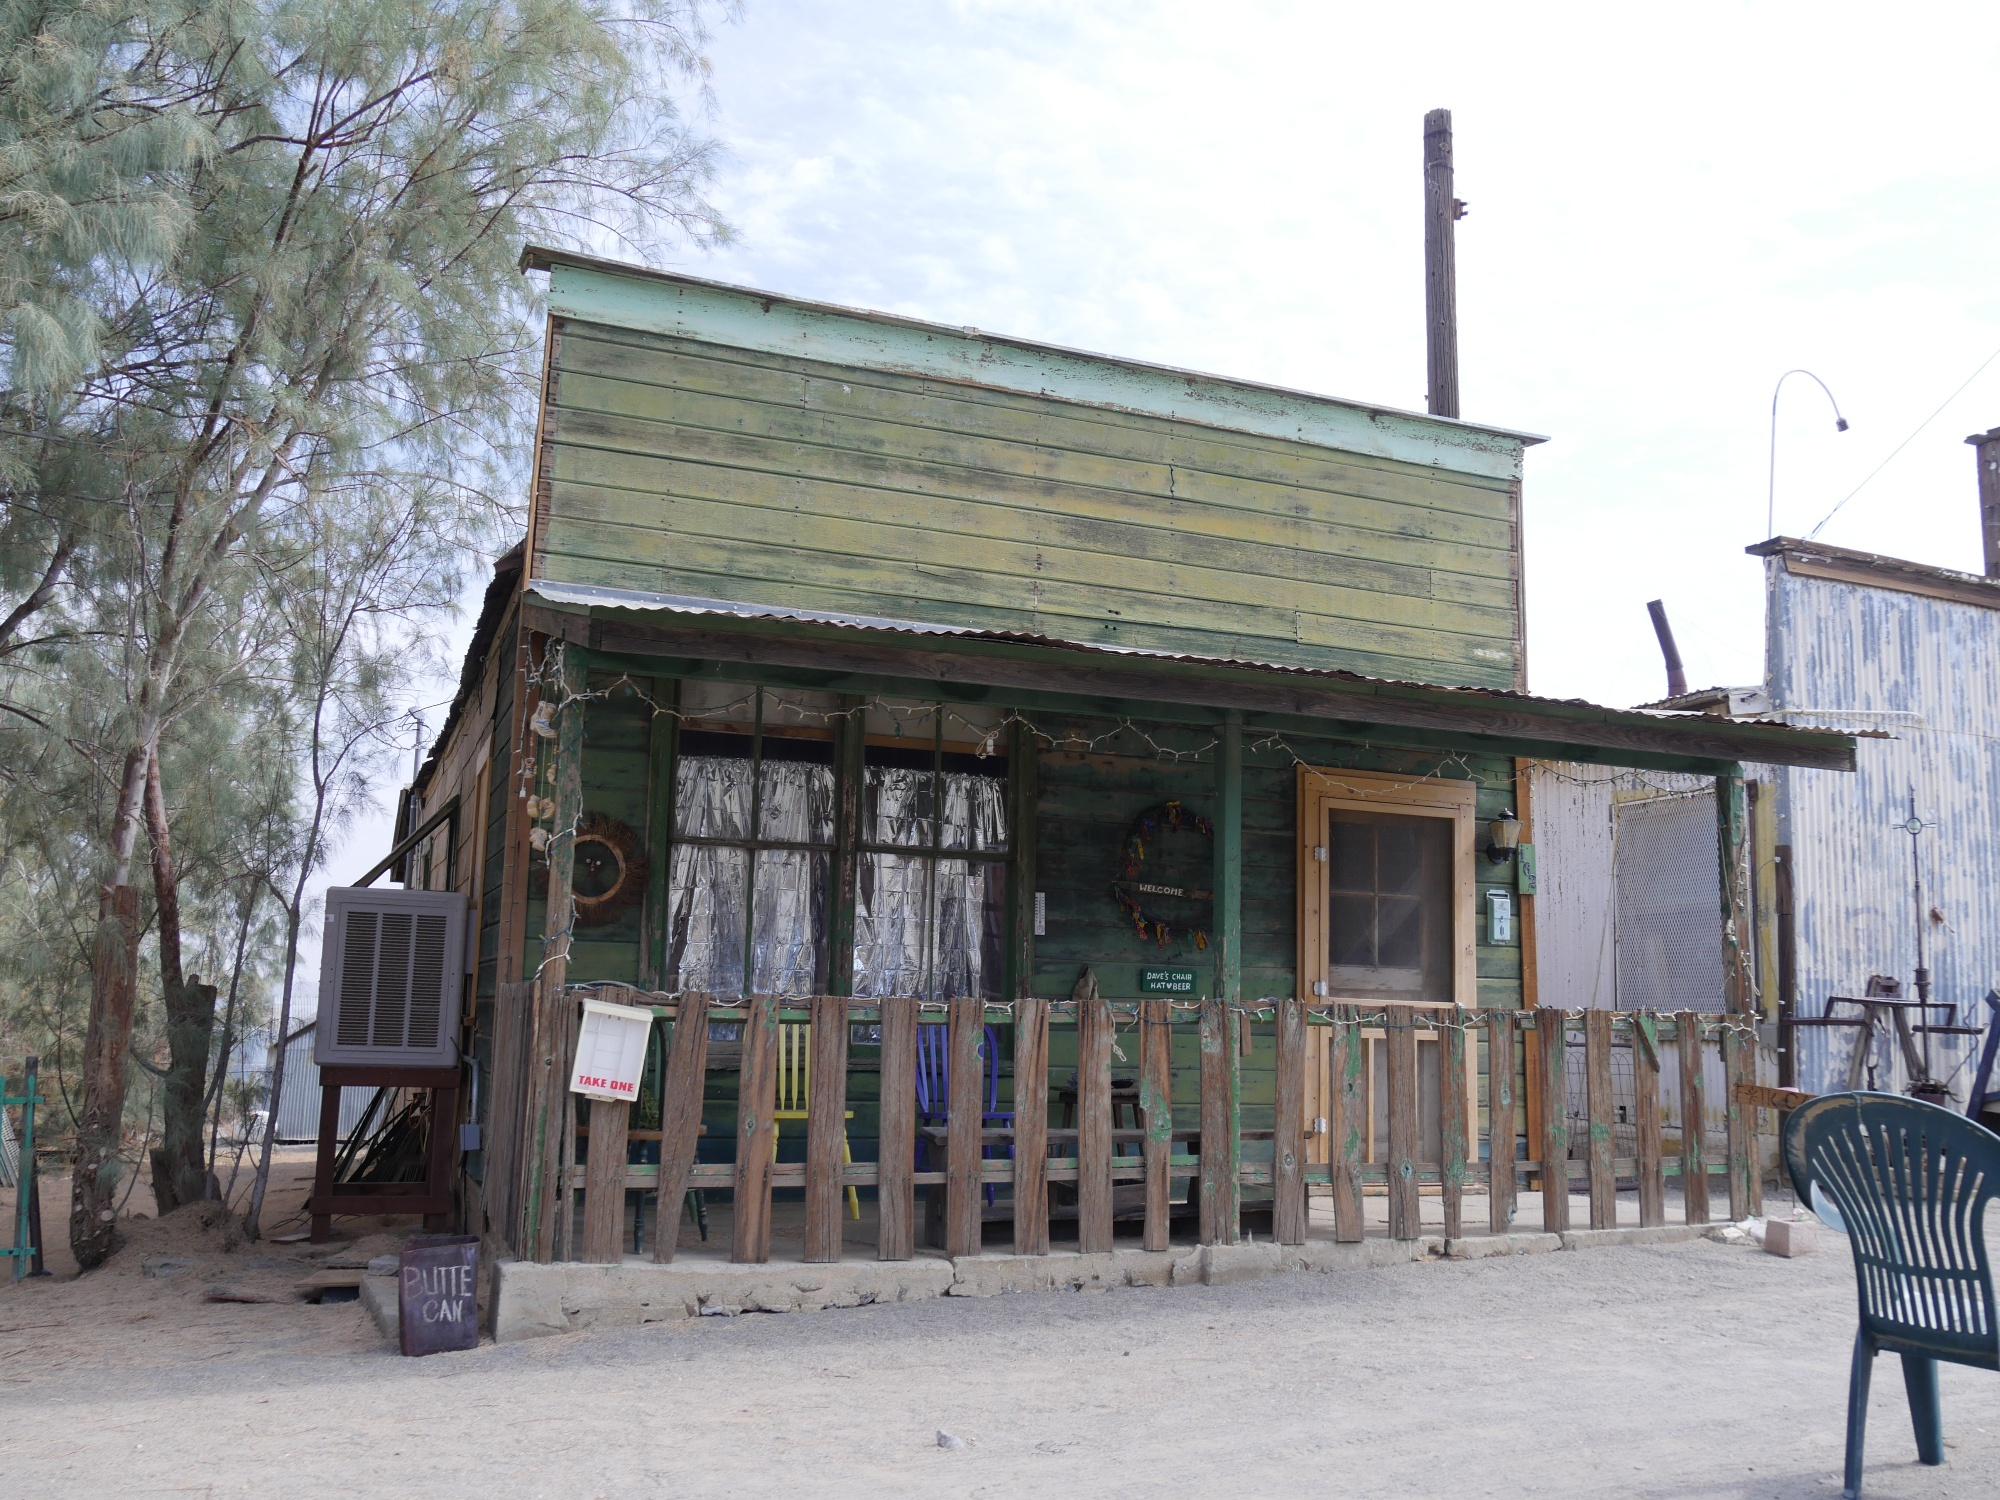Imagine the building could speak. What story would it tell? If the building could speak, it would tell you a tale of resilience and passage through time. 'I’ve stood here through summer suns and winter chills, witnessing the ebb and flow of life. My walls echoed with laughter, tales of adventure, and the hum of countless engines belonging to those journeying along Route 66. I saw Henry paint me green, his chosen hue of hope, and I remained a beacon for weary travelers seeking comfort and companionship. Each object around me—chaise, trash can, tires—has its own story, fragments of the lives that once interwove with mine. Though I stand weathered now, I am a testament to the endurance of dreams and the relentless march of time.' 